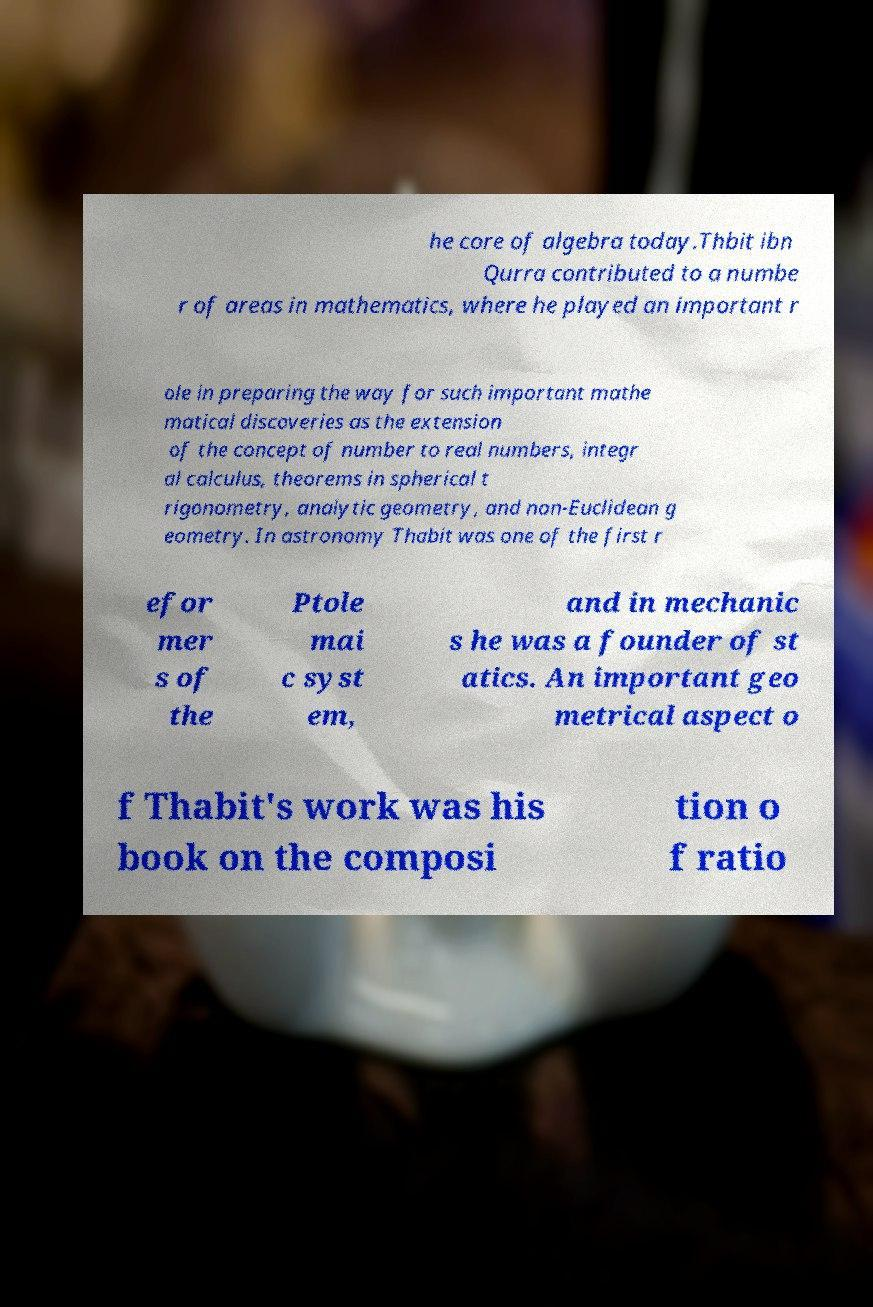Can you read and provide the text displayed in the image?This photo seems to have some interesting text. Can you extract and type it out for me? he core of algebra today.Thbit ibn Qurra contributed to a numbe r of areas in mathematics, where he played an important r ole in preparing the way for such important mathe matical discoveries as the extension of the concept of number to real numbers, integr al calculus, theorems in spherical t rigonometry, analytic geometry, and non-Euclidean g eometry. In astronomy Thabit was one of the first r efor mer s of the Ptole mai c syst em, and in mechanic s he was a founder of st atics. An important geo metrical aspect o f Thabit's work was his book on the composi tion o f ratio 